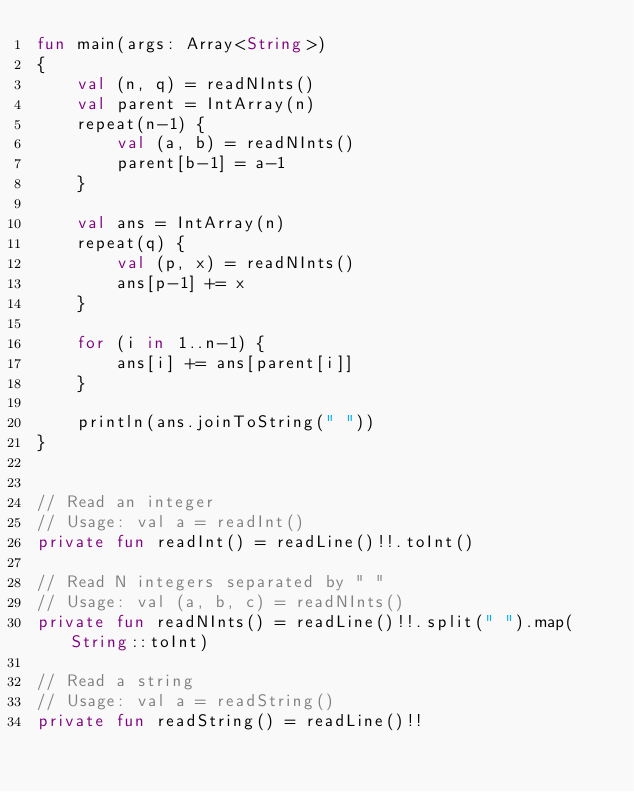<code> <loc_0><loc_0><loc_500><loc_500><_Kotlin_>fun main(args: Array<String>)
{
    val (n, q) = readNInts()
    val parent = IntArray(n)
    repeat(n-1) {
        val (a, b) = readNInts()
        parent[b-1] = a-1
    }

    val ans = IntArray(n)
    repeat(q) {
        val (p, x) = readNInts()
        ans[p-1] += x
    }

    for (i in 1..n-1) {
        ans[i] += ans[parent[i]]
    }

    println(ans.joinToString(" "))
}


// Read an integer
// Usage: val a = readInt()
private fun readInt() = readLine()!!.toInt()

// Read N integers separated by " "
// Usage: val (a, b, c) = readNInts()
private fun readNInts() = readLine()!!.split(" ").map(String::toInt)

// Read a string
// Usage: val a = readString()
private fun readString() = readLine()!!
</code> 